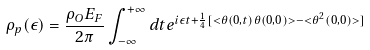Convert formula to latex. <formula><loc_0><loc_0><loc_500><loc_500>\rho _ { p } ( \epsilon ) = \frac { \rho _ { O } E _ { F } } { 2 \pi } \int ^ { + \infty } _ { - \infty } d t e ^ { i \epsilon t + \frac { 1 } { 4 } [ < \theta ( 0 , t ) \theta ( 0 , 0 ) > - < \theta ^ { 2 } ( 0 , 0 ) > ] }</formula> 